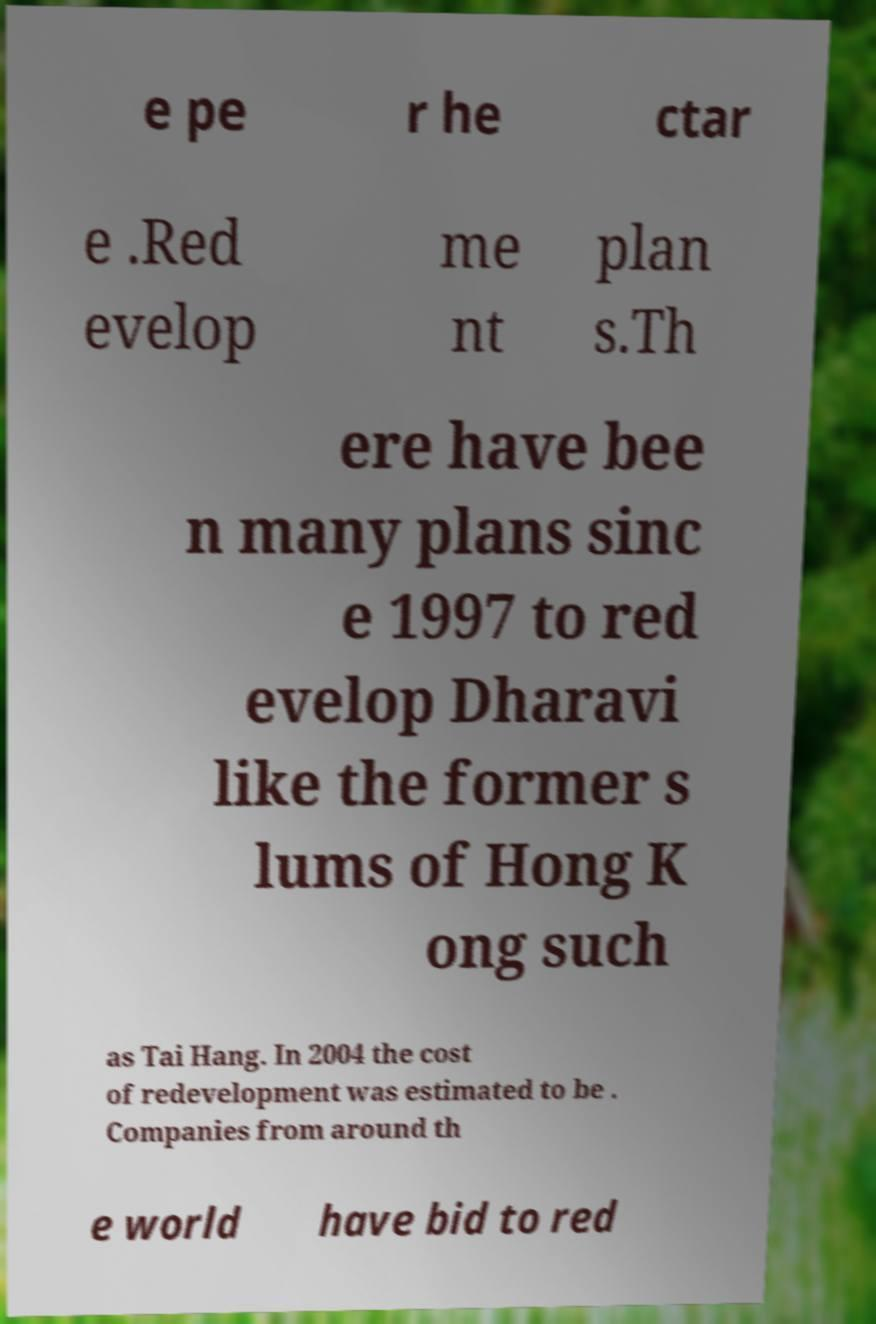Please identify and transcribe the text found in this image. e pe r he ctar e .Red evelop me nt plan s.Th ere have bee n many plans sinc e 1997 to red evelop Dharavi like the former s lums of Hong K ong such as Tai Hang. In 2004 the cost of redevelopment was estimated to be . Companies from around th e world have bid to red 